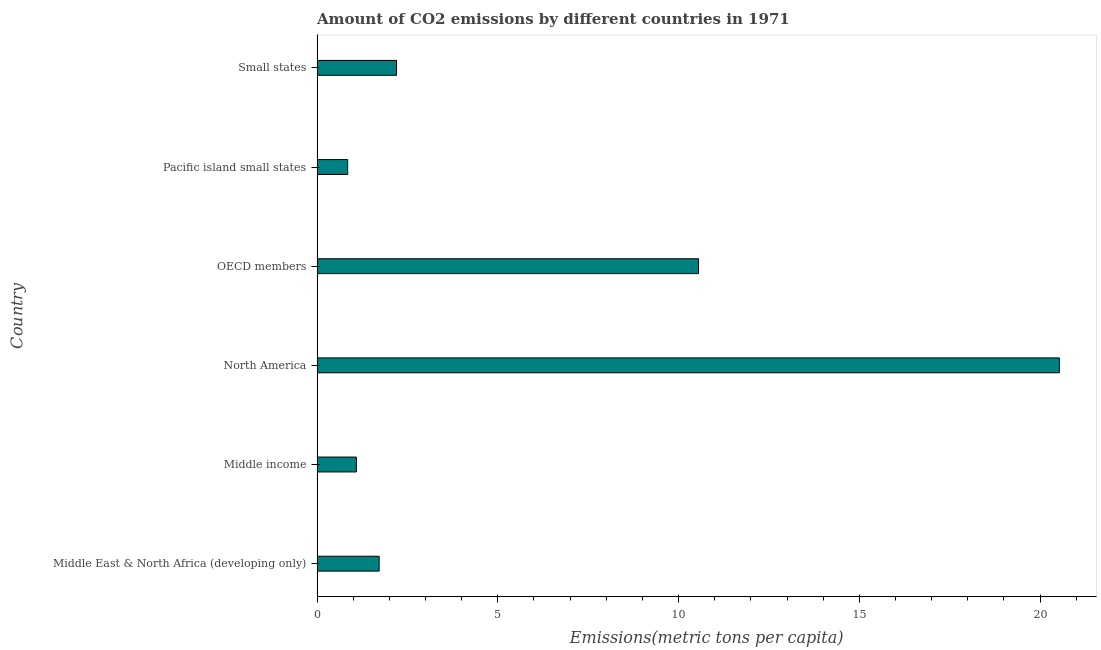What is the title of the graph?
Provide a succinct answer. Amount of CO2 emissions by different countries in 1971. What is the label or title of the X-axis?
Give a very brief answer. Emissions(metric tons per capita). What is the amount of co2 emissions in Middle East & North Africa (developing only)?
Provide a short and direct response. 1.72. Across all countries, what is the maximum amount of co2 emissions?
Make the answer very short. 20.53. Across all countries, what is the minimum amount of co2 emissions?
Your answer should be compact. 0.85. In which country was the amount of co2 emissions maximum?
Your answer should be very brief. North America. In which country was the amount of co2 emissions minimum?
Keep it short and to the point. Pacific island small states. What is the sum of the amount of co2 emissions?
Your response must be concise. 36.94. What is the difference between the amount of co2 emissions in Pacific island small states and Small states?
Keep it short and to the point. -1.35. What is the average amount of co2 emissions per country?
Keep it short and to the point. 6.16. What is the median amount of co2 emissions?
Your answer should be very brief. 1.96. In how many countries, is the amount of co2 emissions greater than 11 metric tons per capita?
Provide a short and direct response. 1. What is the ratio of the amount of co2 emissions in Middle East & North Africa (developing only) to that in Pacific island small states?
Offer a terse response. 2.03. Is the amount of co2 emissions in Middle East & North Africa (developing only) less than that in Pacific island small states?
Your response must be concise. No. Is the difference between the amount of co2 emissions in Middle East & North Africa (developing only) and Middle income greater than the difference between any two countries?
Provide a succinct answer. No. What is the difference between the highest and the second highest amount of co2 emissions?
Offer a terse response. 9.98. Is the sum of the amount of co2 emissions in Middle East & North Africa (developing only) and Middle income greater than the maximum amount of co2 emissions across all countries?
Offer a very short reply. No. What is the difference between the highest and the lowest amount of co2 emissions?
Your response must be concise. 19.69. In how many countries, is the amount of co2 emissions greater than the average amount of co2 emissions taken over all countries?
Your answer should be very brief. 2. Are all the bars in the graph horizontal?
Ensure brevity in your answer.  Yes. What is the Emissions(metric tons per capita) in Middle East & North Africa (developing only)?
Provide a short and direct response. 1.72. What is the Emissions(metric tons per capita) in Middle income?
Offer a terse response. 1.09. What is the Emissions(metric tons per capita) of North America?
Make the answer very short. 20.53. What is the Emissions(metric tons per capita) in OECD members?
Give a very brief answer. 10.55. What is the Emissions(metric tons per capita) in Pacific island small states?
Your answer should be very brief. 0.85. What is the Emissions(metric tons per capita) of Small states?
Give a very brief answer. 2.2. What is the difference between the Emissions(metric tons per capita) in Middle East & North Africa (developing only) and Middle income?
Keep it short and to the point. 0.63. What is the difference between the Emissions(metric tons per capita) in Middle East & North Africa (developing only) and North America?
Keep it short and to the point. -18.82. What is the difference between the Emissions(metric tons per capita) in Middle East & North Africa (developing only) and OECD members?
Offer a terse response. -8.84. What is the difference between the Emissions(metric tons per capita) in Middle East & North Africa (developing only) and Pacific island small states?
Provide a succinct answer. 0.87. What is the difference between the Emissions(metric tons per capita) in Middle East & North Africa (developing only) and Small states?
Make the answer very short. -0.48. What is the difference between the Emissions(metric tons per capita) in Middle income and North America?
Keep it short and to the point. -19.45. What is the difference between the Emissions(metric tons per capita) in Middle income and OECD members?
Your answer should be very brief. -9.47. What is the difference between the Emissions(metric tons per capita) in Middle income and Pacific island small states?
Make the answer very short. 0.24. What is the difference between the Emissions(metric tons per capita) in Middle income and Small states?
Ensure brevity in your answer.  -1.11. What is the difference between the Emissions(metric tons per capita) in North America and OECD members?
Make the answer very short. 9.98. What is the difference between the Emissions(metric tons per capita) in North America and Pacific island small states?
Your answer should be compact. 19.69. What is the difference between the Emissions(metric tons per capita) in North America and Small states?
Provide a short and direct response. 18.34. What is the difference between the Emissions(metric tons per capita) in OECD members and Pacific island small states?
Keep it short and to the point. 9.71. What is the difference between the Emissions(metric tons per capita) in OECD members and Small states?
Keep it short and to the point. 8.35. What is the difference between the Emissions(metric tons per capita) in Pacific island small states and Small states?
Make the answer very short. -1.35. What is the ratio of the Emissions(metric tons per capita) in Middle East & North Africa (developing only) to that in Middle income?
Offer a terse response. 1.58. What is the ratio of the Emissions(metric tons per capita) in Middle East & North Africa (developing only) to that in North America?
Offer a terse response. 0.08. What is the ratio of the Emissions(metric tons per capita) in Middle East & North Africa (developing only) to that in OECD members?
Offer a terse response. 0.16. What is the ratio of the Emissions(metric tons per capita) in Middle East & North Africa (developing only) to that in Pacific island small states?
Your answer should be compact. 2.03. What is the ratio of the Emissions(metric tons per capita) in Middle East & North Africa (developing only) to that in Small states?
Your response must be concise. 0.78. What is the ratio of the Emissions(metric tons per capita) in Middle income to that in North America?
Make the answer very short. 0.05. What is the ratio of the Emissions(metric tons per capita) in Middle income to that in OECD members?
Make the answer very short. 0.1. What is the ratio of the Emissions(metric tons per capita) in Middle income to that in Pacific island small states?
Give a very brief answer. 1.28. What is the ratio of the Emissions(metric tons per capita) in Middle income to that in Small states?
Ensure brevity in your answer.  0.49. What is the ratio of the Emissions(metric tons per capita) in North America to that in OECD members?
Provide a succinct answer. 1.95. What is the ratio of the Emissions(metric tons per capita) in North America to that in Pacific island small states?
Offer a terse response. 24.25. What is the ratio of the Emissions(metric tons per capita) in North America to that in Small states?
Ensure brevity in your answer.  9.34. What is the ratio of the Emissions(metric tons per capita) in OECD members to that in Pacific island small states?
Provide a succinct answer. 12.46. What is the ratio of the Emissions(metric tons per capita) in Pacific island small states to that in Small states?
Offer a very short reply. 0.39. 